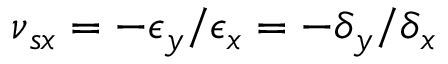<formula> <loc_0><loc_0><loc_500><loc_500>\nu { _ { s x } } = - \epsilon { _ { y } } / \epsilon { _ { x } } = - \delta { _ { y } } / \delta { _ { x } }</formula> 